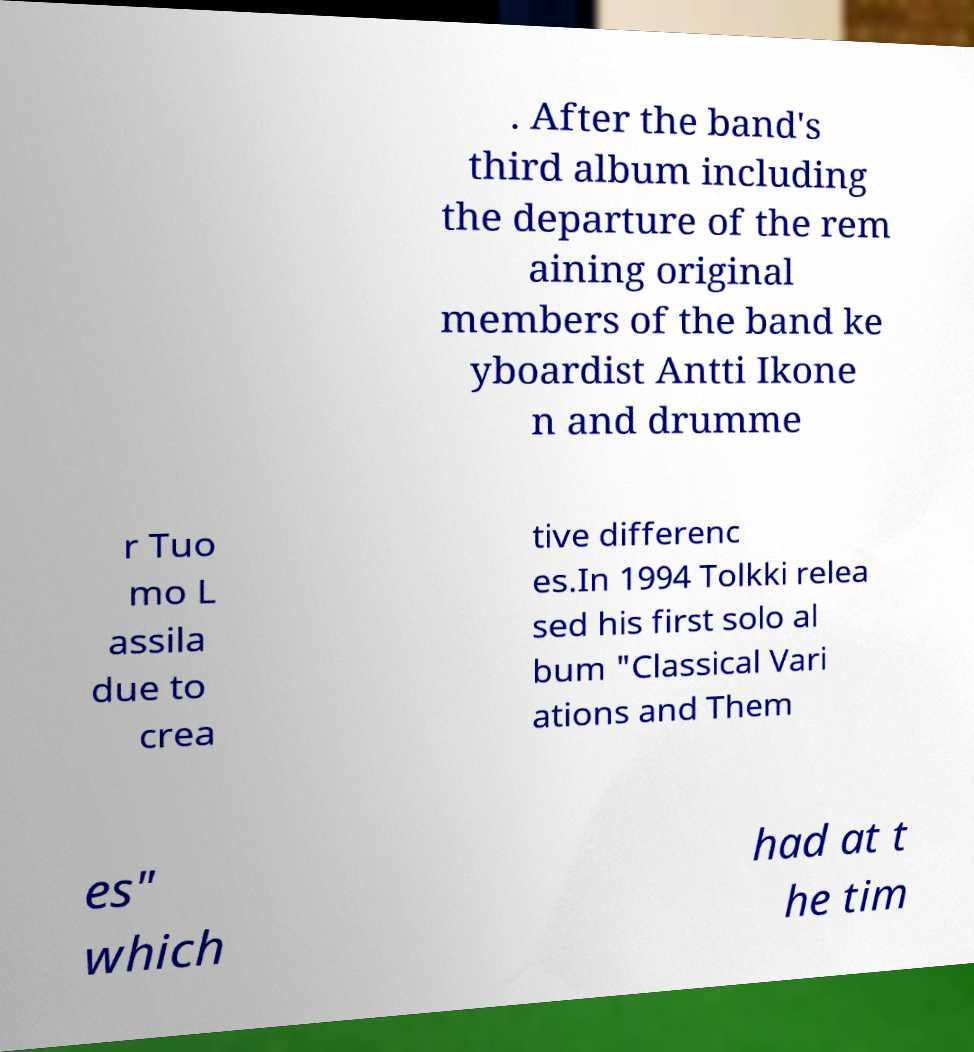Could you assist in decoding the text presented in this image and type it out clearly? . After the band's third album including the departure of the rem aining original members of the band ke yboardist Antti Ikone n and drumme r Tuo mo L assila due to crea tive differenc es.In 1994 Tolkki relea sed his first solo al bum "Classical Vari ations and Them es" which had at t he tim 